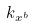<formula> <loc_0><loc_0><loc_500><loc_500>k _ { x ^ { b } }</formula> 